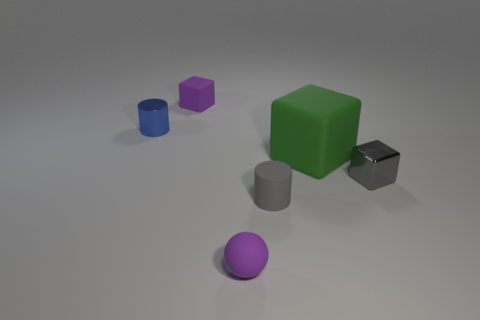What shape is the matte object that is the same color as the tiny matte block?
Offer a terse response. Sphere. Is the number of big green cylinders greater than the number of matte cubes?
Keep it short and to the point. No. How many large blocks are in front of the tiny purple matte object that is behind the small metallic cylinder?
Give a very brief answer. 1. What number of objects are gray things that are left of the large rubber object or small matte cylinders?
Offer a very short reply. 1. Are there any other tiny blue shiny things that have the same shape as the small blue thing?
Your answer should be compact. No. What is the shape of the purple thing that is behind the small object right of the rubber cylinder?
Make the answer very short. Cube. What number of balls are either gray shiny objects or gray matte things?
Your answer should be compact. 0. What material is the tiny cube that is the same color as the tiny matte ball?
Your answer should be compact. Rubber. There is a shiny object in front of the tiny blue object; is its shape the same as the metal object that is behind the big green object?
Your response must be concise. No. The small thing that is on the right side of the blue metal thing and behind the large rubber thing is what color?
Your answer should be very brief. Purple. 